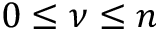<formula> <loc_0><loc_0><loc_500><loc_500>0 \leq \nu \leq n</formula> 